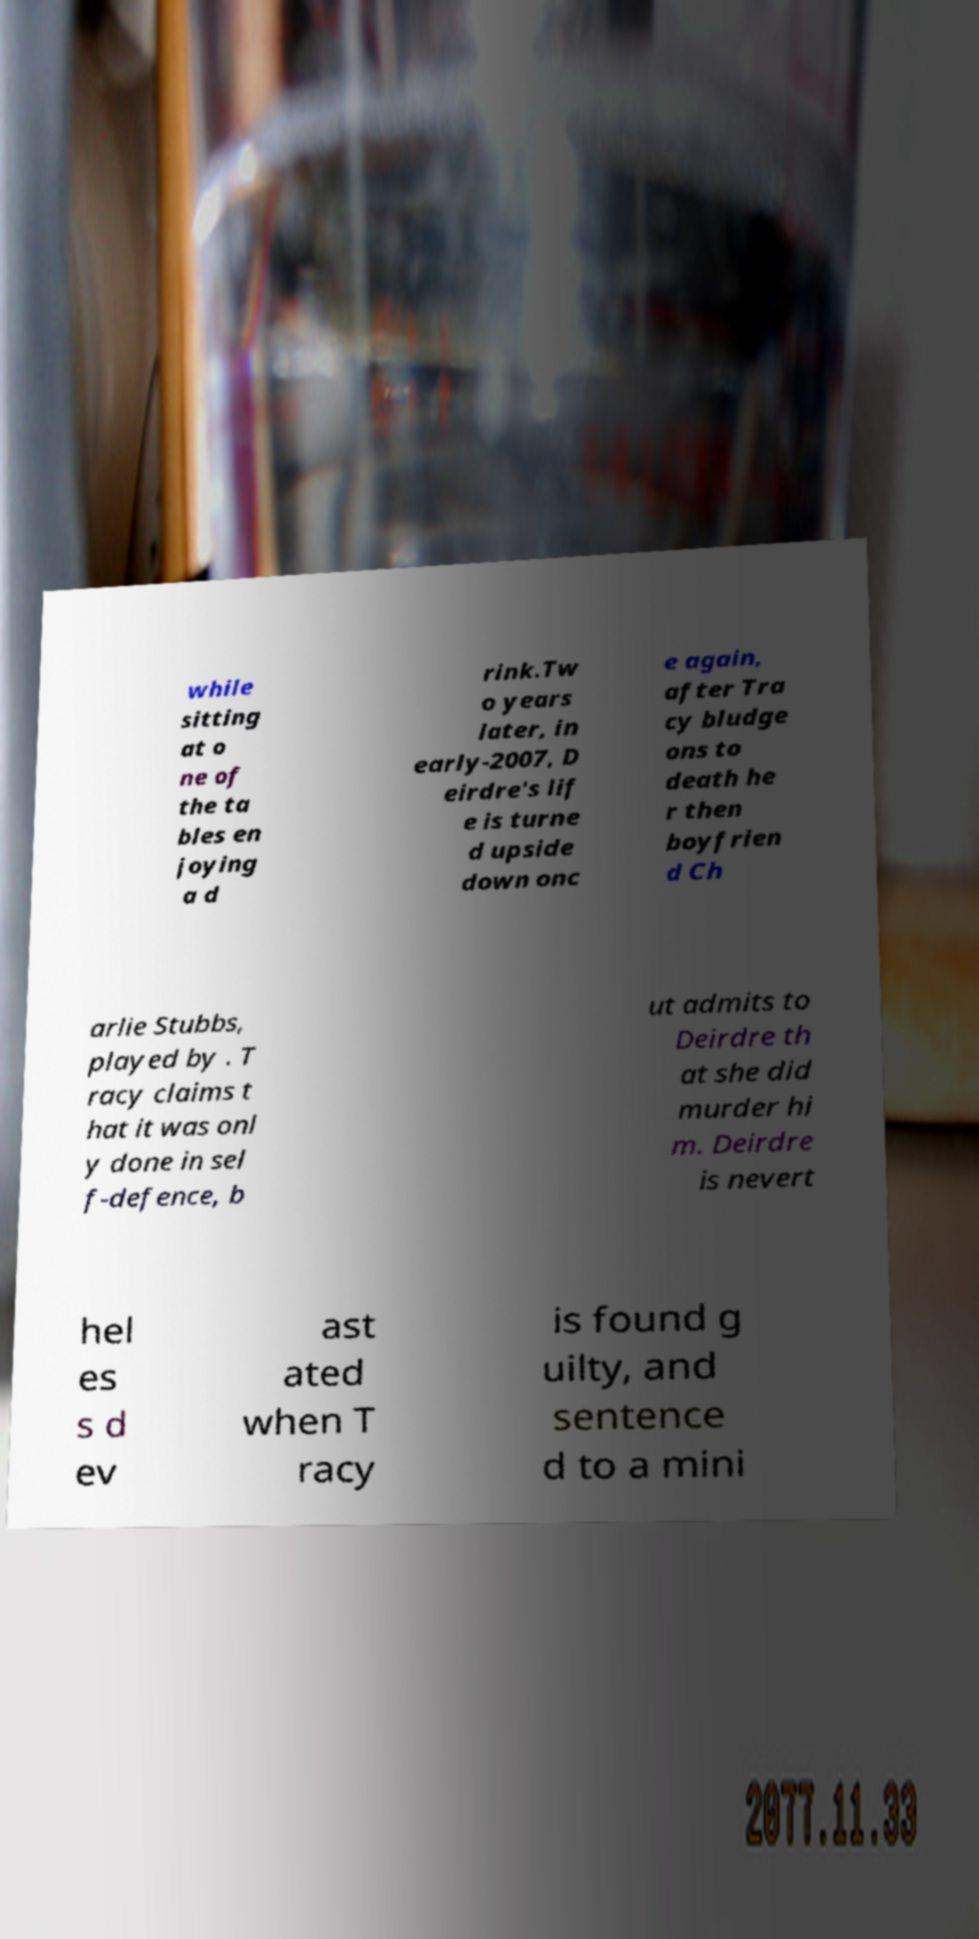What messages or text are displayed in this image? I need them in a readable, typed format. while sitting at o ne of the ta bles en joying a d rink.Tw o years later, in early-2007, D eirdre's lif e is turne d upside down onc e again, after Tra cy bludge ons to death he r then boyfrien d Ch arlie Stubbs, played by . T racy claims t hat it was onl y done in sel f-defence, b ut admits to Deirdre th at she did murder hi m. Deirdre is nevert hel es s d ev ast ated when T racy is found g uilty, and sentence d to a mini 